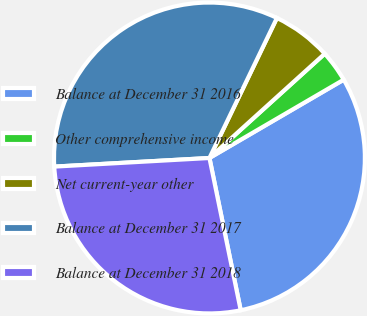<chart> <loc_0><loc_0><loc_500><loc_500><pie_chart><fcel>Balance at December 31 2016<fcel>Other comprehensive income<fcel>Net current-year other<fcel>Balance at December 31 2017<fcel>Balance at December 31 2018<nl><fcel>30.18%<fcel>3.3%<fcel>6.15%<fcel>33.03%<fcel>27.34%<nl></chart> 